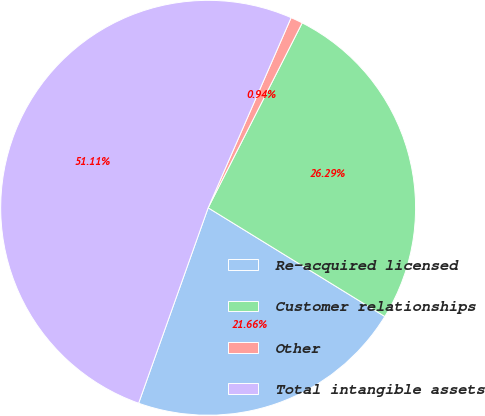<chart> <loc_0><loc_0><loc_500><loc_500><pie_chart><fcel>Re-acquired licensed<fcel>Customer relationships<fcel>Other<fcel>Total intangible assets<nl><fcel>21.66%<fcel>26.29%<fcel>0.94%<fcel>51.11%<nl></chart> 